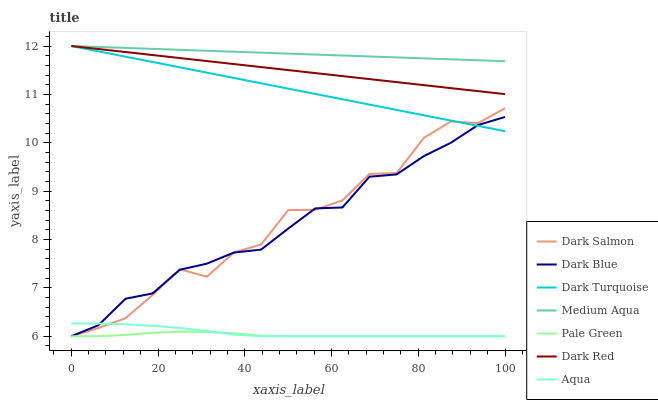Does Pale Green have the minimum area under the curve?
Answer yes or no. Yes. Does Medium Aqua have the maximum area under the curve?
Answer yes or no. Yes. Does Aqua have the minimum area under the curve?
Answer yes or no. No. Does Aqua have the maximum area under the curve?
Answer yes or no. No. Is Medium Aqua the smoothest?
Answer yes or no. Yes. Is Dark Salmon the roughest?
Answer yes or no. Yes. Is Aqua the smoothest?
Answer yes or no. No. Is Aqua the roughest?
Answer yes or no. No. Does Aqua have the lowest value?
Answer yes or no. Yes. Does Medium Aqua have the lowest value?
Answer yes or no. No. Does Dark Turquoise have the highest value?
Answer yes or no. Yes. Does Aqua have the highest value?
Answer yes or no. No. Is Aqua less than Medium Aqua?
Answer yes or no. Yes. Is Dark Red greater than Aqua?
Answer yes or no. Yes. Does Dark Blue intersect Dark Turquoise?
Answer yes or no. Yes. Is Dark Blue less than Dark Turquoise?
Answer yes or no. No. Is Dark Blue greater than Dark Turquoise?
Answer yes or no. No. Does Aqua intersect Medium Aqua?
Answer yes or no. No. 